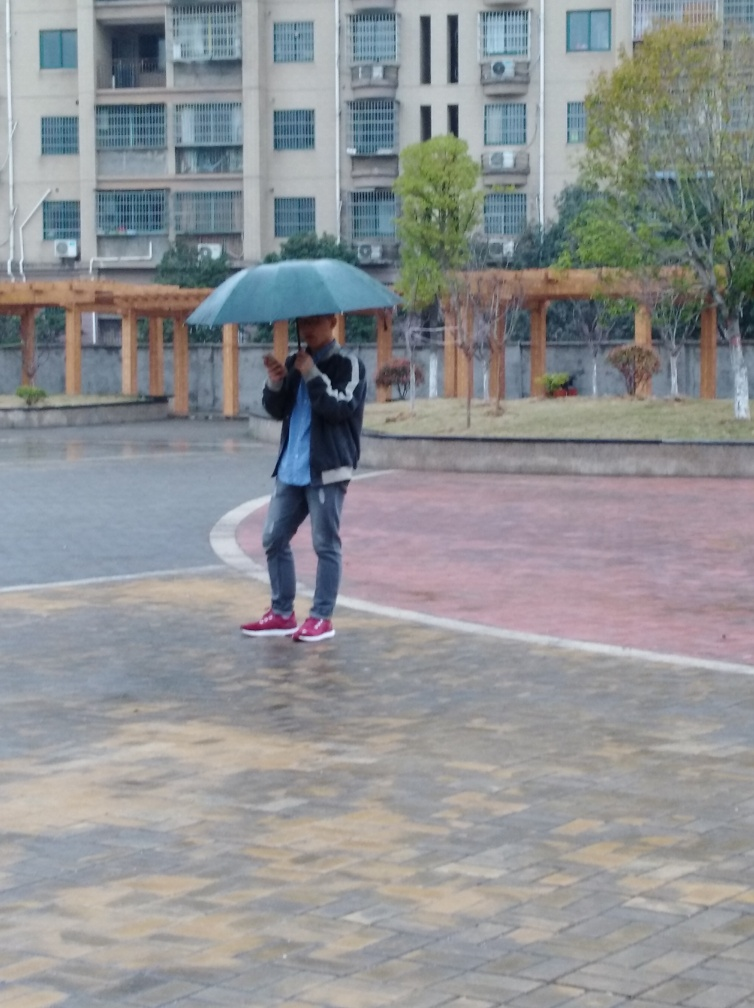Describe the setting of this image. The image depicts an urban outdoor area, likely a public square or courtyard, surrounded by apartment buildings. It's a wide-open space with trees and a pergola, which suggests it may be a common area intended for residents or visitors to enjoy. Does the environment look well maintained? The area appears to be in fair condition with clean paved paths and pruned trees. The buildings in the background show some signs of wear but nothing that suggests neglect. 